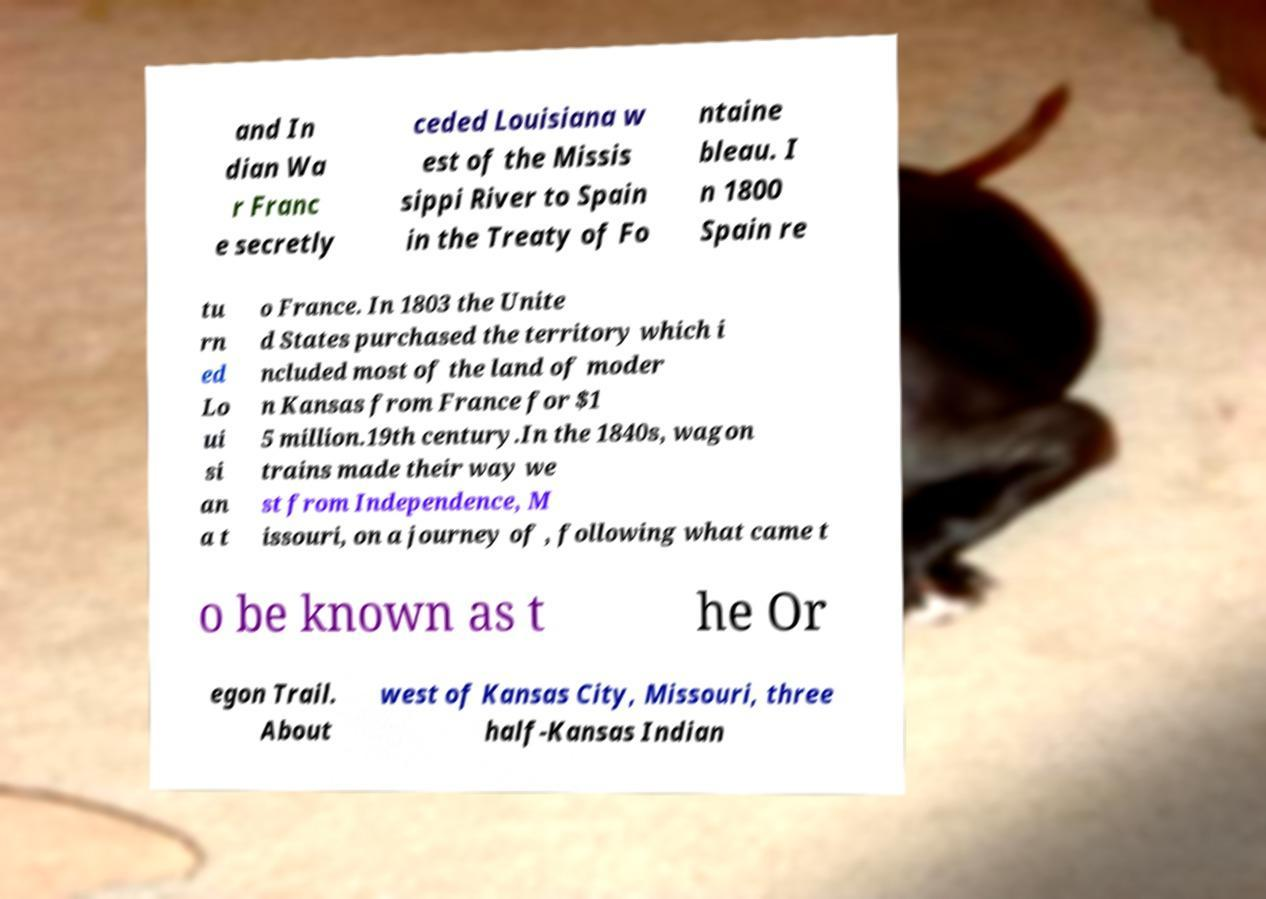I need the written content from this picture converted into text. Can you do that? and In dian Wa r Franc e secretly ceded Louisiana w est of the Missis sippi River to Spain in the Treaty of Fo ntaine bleau. I n 1800 Spain re tu rn ed Lo ui si an a t o France. In 1803 the Unite d States purchased the territory which i ncluded most of the land of moder n Kansas from France for $1 5 million.19th century.In the 1840s, wagon trains made their way we st from Independence, M issouri, on a journey of , following what came t o be known as t he Or egon Trail. About west of Kansas City, Missouri, three half-Kansas Indian 